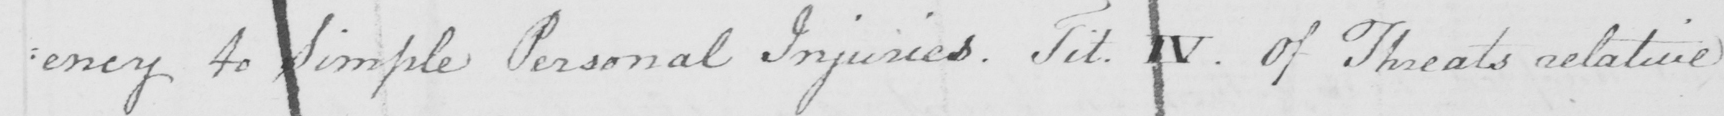Please transcribe the handwritten text in this image. : ency to Simple Personal Injuries . Tit . IV . Of Threats relative 